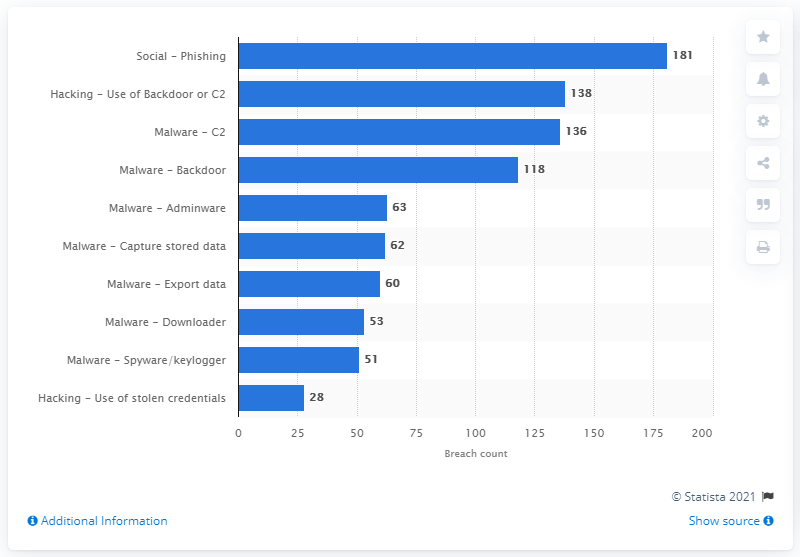Specify some key components in this picture. The data indicates that 181 cyber espionage incidents involved the use of phishing tactics. According to data, 28 cyber espionage data breaches involved phishing. 